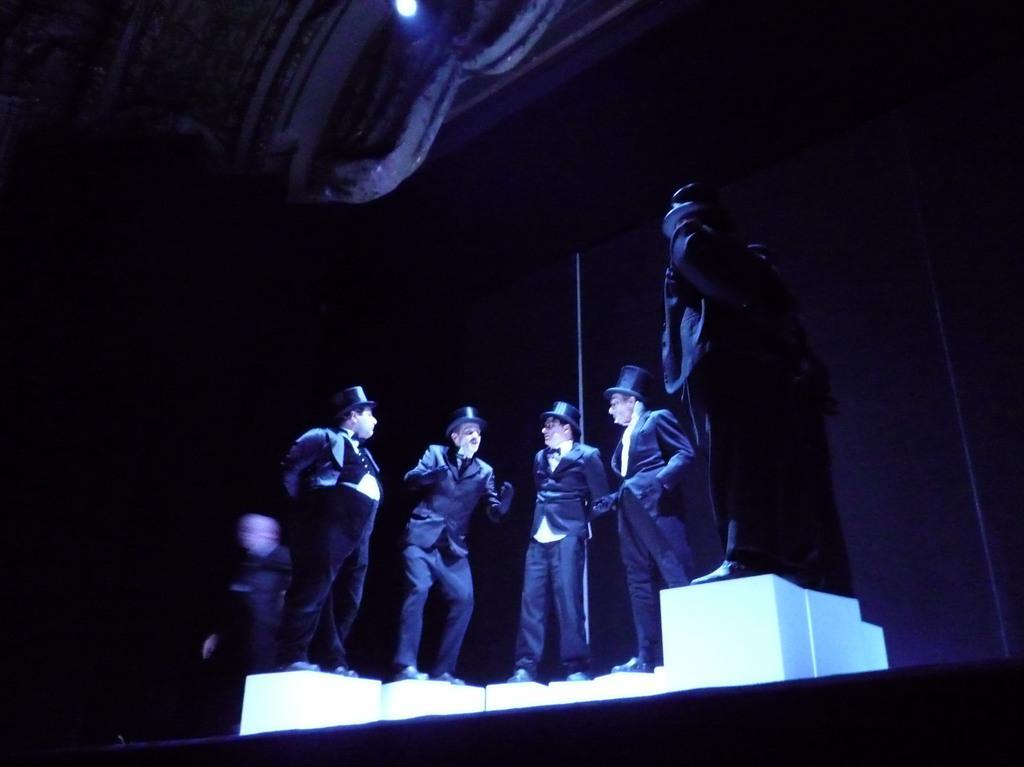How would you summarize this image in a sentence or two? In this picture we can see for persons standing, they wore suits, gloves, shoes and caps, on the right side there is a statue, we can see a light at the top of the picture. 